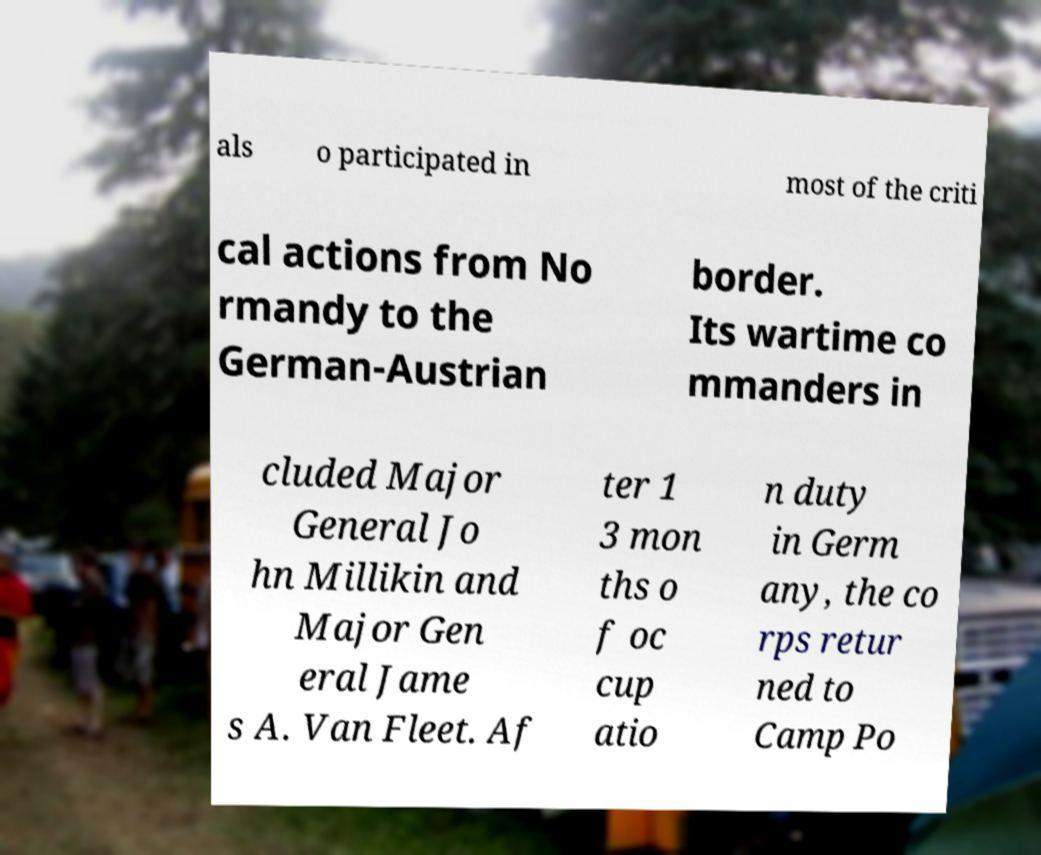Please read and relay the text visible in this image. What does it say? als o participated in most of the criti cal actions from No rmandy to the German-Austrian border. Its wartime co mmanders in cluded Major General Jo hn Millikin and Major Gen eral Jame s A. Van Fleet. Af ter 1 3 mon ths o f oc cup atio n duty in Germ any, the co rps retur ned to Camp Po 